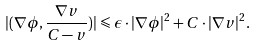Convert formula to latex. <formula><loc_0><loc_0><loc_500><loc_500>| ( \nabla \phi , \frac { \nabla v } { C - v } ) | \leqslant \epsilon \cdot | \nabla \phi | ^ { 2 } + C \cdot | \nabla v | ^ { 2 } .</formula> 